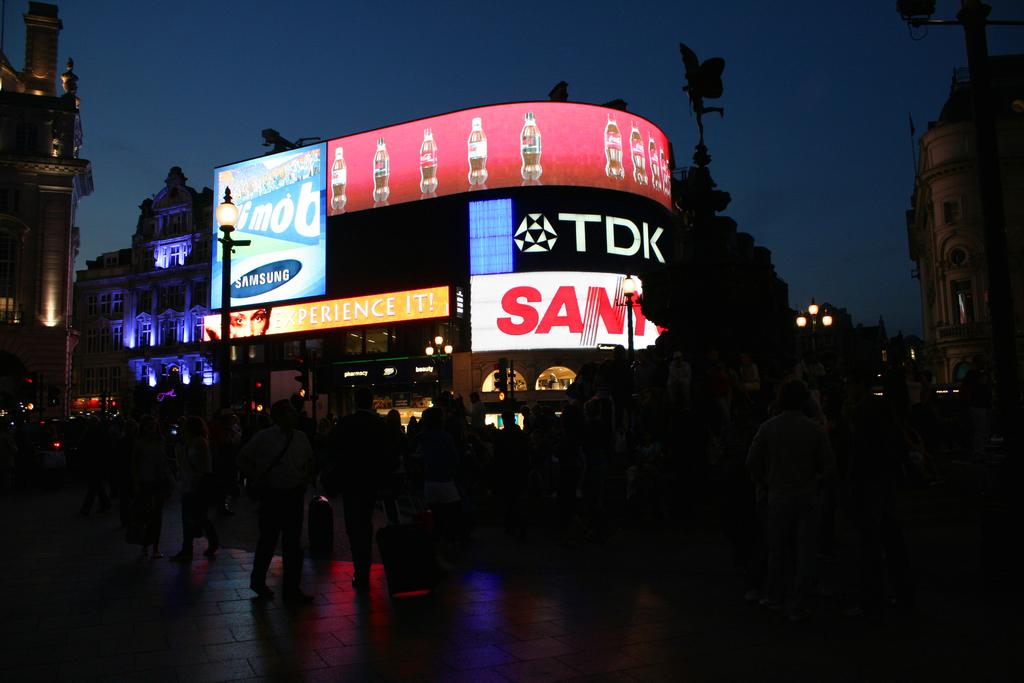What are the people in the image doing? The group of people is standing on the road. What can be seen in the distance behind the people? There are buildings, a statue, and traffic lights visible in the background. What other objects can be seen in the background? There are poles and street poles in the background. What is visible above the background objects? The sky is visible in the background. What type of cloth is being used to build the nest in the image? There is no nest or cloth present in the image. How many geese are visible in the image? There are no geese present in the image. 